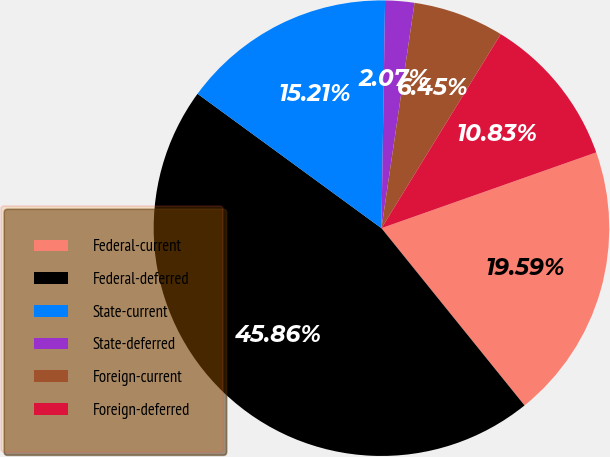Convert chart. <chart><loc_0><loc_0><loc_500><loc_500><pie_chart><fcel>Federal-current<fcel>Federal-deferred<fcel>State-current<fcel>State-deferred<fcel>Foreign-current<fcel>Foreign-deferred<nl><fcel>19.59%<fcel>45.86%<fcel>15.21%<fcel>2.07%<fcel>6.45%<fcel>10.83%<nl></chart> 